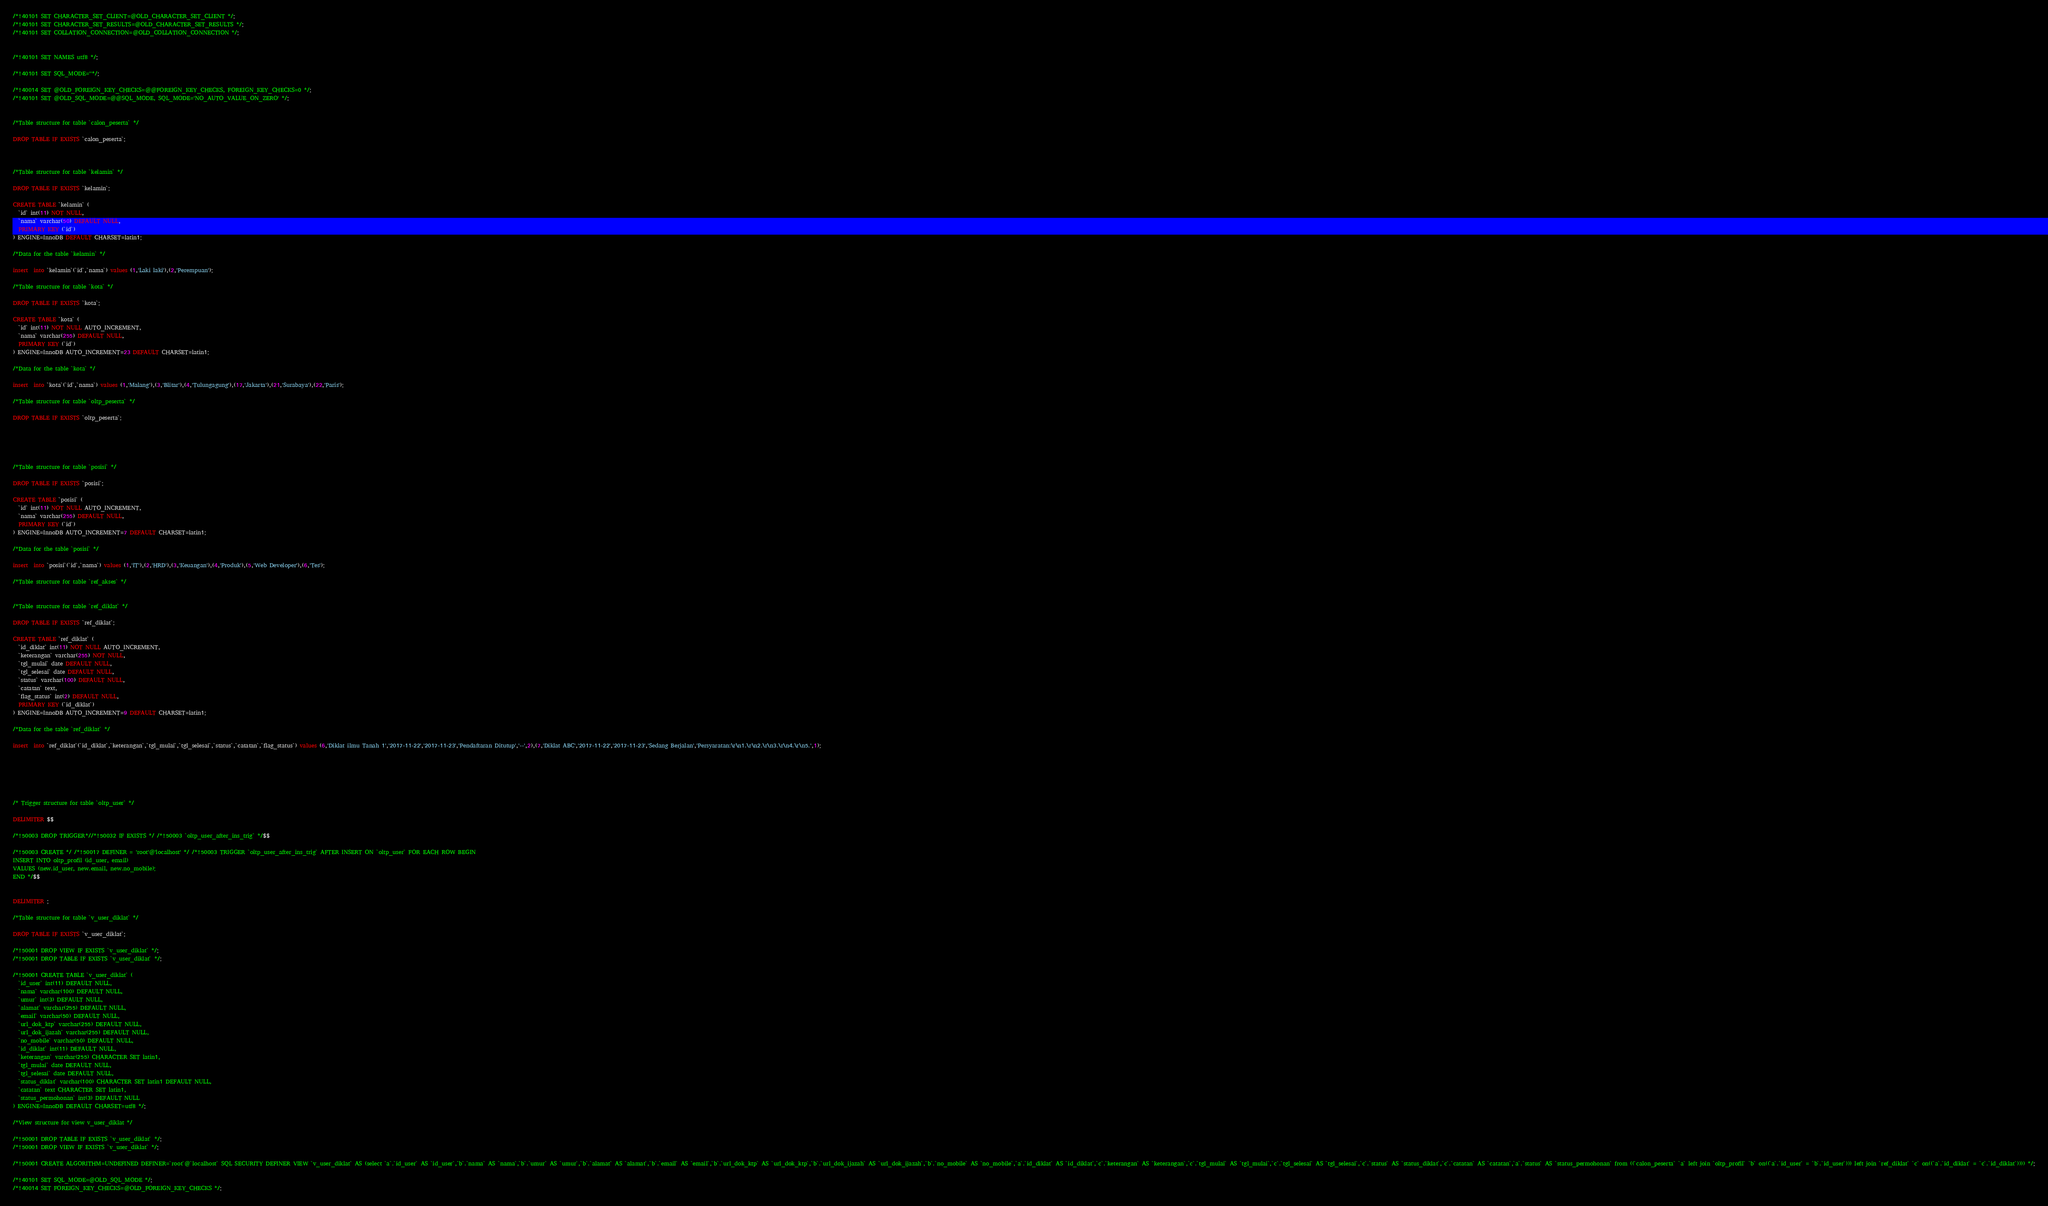<code> <loc_0><loc_0><loc_500><loc_500><_SQL_>/*!40101 SET CHARACTER_SET_CLIENT=@OLD_CHARACTER_SET_CLIENT */;
/*!40101 SET CHARACTER_SET_RESULTS=@OLD_CHARACTER_SET_RESULTS */;
/*!40101 SET COLLATION_CONNECTION=@OLD_COLLATION_CONNECTION */;


/*!40101 SET NAMES utf8 */;

/*!40101 SET SQL_MODE=''*/;

/*!40014 SET @OLD_FOREIGN_KEY_CHECKS=@@FOREIGN_KEY_CHECKS, FOREIGN_KEY_CHECKS=0 */;
/*!40101 SET @OLD_SQL_MODE=@@SQL_MODE, SQL_MODE='NO_AUTO_VALUE_ON_ZERO' */;


/*Table structure for table `calon_peserta` */

DROP TABLE IF EXISTS `calon_peserta`;



/*Table structure for table `kelamin` */

DROP TABLE IF EXISTS `kelamin`;

CREATE TABLE `kelamin` (
  `id` int(11) NOT NULL,
  `nama` varchar(50) DEFAULT NULL,
  PRIMARY KEY (`id`)
) ENGINE=InnoDB DEFAULT CHARSET=latin1;

/*Data for the table `kelamin` */

insert  into `kelamin`(`id`,`nama`) values (1,'Laki laki'),(2,'Perempuan');

/*Table structure for table `kota` */

DROP TABLE IF EXISTS `kota`;

CREATE TABLE `kota` (
  `id` int(11) NOT NULL AUTO_INCREMENT,
  `nama` varchar(255) DEFAULT NULL,
  PRIMARY KEY (`id`)
) ENGINE=InnoDB AUTO_INCREMENT=23 DEFAULT CHARSET=latin1;

/*Data for the table `kota` */

insert  into `kota`(`id`,`nama`) values (1,'Malang'),(3,'Blitar'),(4,'Tulungagung'),(17,'Jakarta'),(21,'Surabaya'),(22,'Paris');

/*Table structure for table `oltp_peserta` */

DROP TABLE IF EXISTS `oltp_peserta`;





/*Table structure for table `posisi` */

DROP TABLE IF EXISTS `posisi`;

CREATE TABLE `posisi` (
  `id` int(11) NOT NULL AUTO_INCREMENT,
  `nama` varchar(255) DEFAULT NULL,
  PRIMARY KEY (`id`)
) ENGINE=InnoDB AUTO_INCREMENT=7 DEFAULT CHARSET=latin1;

/*Data for the table `posisi` */

insert  into `posisi`(`id`,`nama`) values (1,'IT'),(2,'HRD'),(3,'Keuangan'),(4,'Produk'),(5,'Web Developer'),(6,'Tes');

/*Table structure for table `ref_akses` */


/*Table structure for table `ref_diklat` */

DROP TABLE IF EXISTS `ref_diklat`;

CREATE TABLE `ref_diklat` (
  `id_diklat` int(11) NOT NULL AUTO_INCREMENT,
  `keterangan` varchar(255) NOT NULL,
  `tgl_mulai` date DEFAULT NULL,
  `tgl_selesai` date DEFAULT NULL,
  `status` varchar(100) DEFAULT NULL,
  `catatan` text,
  `flag_status` int(2) DEFAULT NULL,
  PRIMARY KEY (`id_diklat`)
) ENGINE=InnoDB AUTO_INCREMENT=9 DEFAULT CHARSET=latin1;

/*Data for the table `ref_diklat` */

insert  into `ref_diklat`(`id_diklat`,`keterangan`,`tgl_mulai`,`tgl_selesai`,`status`,`catatan`,`flag_status`) values (6,'Diklat ilmu Tanah 1','2017-11-22','2017-11-23','Pendaftaran Ditutup','--',2),(7,'Diklat ABC','2017-11-22','2017-11-23','Sedang Berjalan','Persyaratan:\r\n1.\r\n2.\r\n3.\r\n4.\r\n5.',1);






/* Trigger structure for table `oltp_user` */

DELIMITER $$

/*!50003 DROP TRIGGER*//*!50032 IF EXISTS */ /*!50003 `oltp_user_after_ins_trig` */$$

/*!50003 CREATE */ /*!50017 DEFINER = 'root'@'localhost' */ /*!50003 TRIGGER `oltp_user_after_ins_trig` AFTER INSERT ON `oltp_user` FOR EACH ROW BEGIN
INSERT INTO oltp_profil (id_user, email)
VALUES (new.id_user, new.email, new.no_mobile);
END */$$


DELIMITER ;

/*Table structure for table `v_user_diklat` */

DROP TABLE IF EXISTS `v_user_diklat`;

/*!50001 DROP VIEW IF EXISTS `v_user_diklat` */;
/*!50001 DROP TABLE IF EXISTS `v_user_diklat` */;

/*!50001 CREATE TABLE `v_user_diklat` (
  `id_user` int(11) DEFAULT NULL,
  `nama` varchar(100) DEFAULT NULL,
  `umur` int(3) DEFAULT NULL,
  `alamat` varchar(255) DEFAULT NULL,
  `email` varchar(50) DEFAULT NULL,
  `url_dok_ktp` varchar(255) DEFAULT NULL,
  `url_dok_ijazah` varchar(255) DEFAULT NULL,
  `no_mobile` varchar(50) DEFAULT NULL,
  `id_diklat` int(11) DEFAULT NULL,
  `keterangan` varchar(255) CHARACTER SET latin1,
  `tgl_mulai` date DEFAULT NULL,
  `tgl_selesai` date DEFAULT NULL,
  `status_diklat` varchar(100) CHARACTER SET latin1 DEFAULT NULL,
  `catatan` text CHARACTER SET latin1,
  `status_permohonan` int(3) DEFAULT NULL
) ENGINE=InnoDB DEFAULT CHARSET=utf8 */;

/*View structure for view v_user_diklat */

/*!50001 DROP TABLE IF EXISTS `v_user_diklat` */;
/*!50001 DROP VIEW IF EXISTS `v_user_diklat` */;

/*!50001 CREATE ALGORITHM=UNDEFINED DEFINER=`root`@`localhost` SQL SECURITY DEFINER VIEW `v_user_diklat` AS (select `a`.`id_user` AS `id_user`,`b`.`nama` AS `nama`,`b`.`umur` AS `umur`,`b`.`alamat` AS `alamat`,`b`.`email` AS `email`,`b`.`url_dok_ktp` AS `url_dok_ktp`,`b`.`url_dok_ijazah` AS `url_dok_ijazah`,`b`.`no_mobile` AS `no_mobile`,`a`.`id_diklat` AS `id_diklat`,`c`.`keterangan` AS `keterangan`,`c`.`tgl_mulai` AS `tgl_mulai`,`c`.`tgl_selesai` AS `tgl_selesai`,`c`.`status` AS `status_diklat`,`c`.`catatan` AS `catatan`,`a`.`status` AS `status_permohonan` from ((`calon_peserta` `a` left join `oltp_profil` `b` on((`a`.`id_user` = `b`.`id_user`))) left join `ref_diklat` `c` on((`a`.`id_diklat` = `c`.`id_diklat`)))) */;

/*!40101 SET SQL_MODE=@OLD_SQL_MODE */;
/*!40014 SET FOREIGN_KEY_CHECKS=@OLD_FOREIGN_KEY_CHECKS */;
</code> 